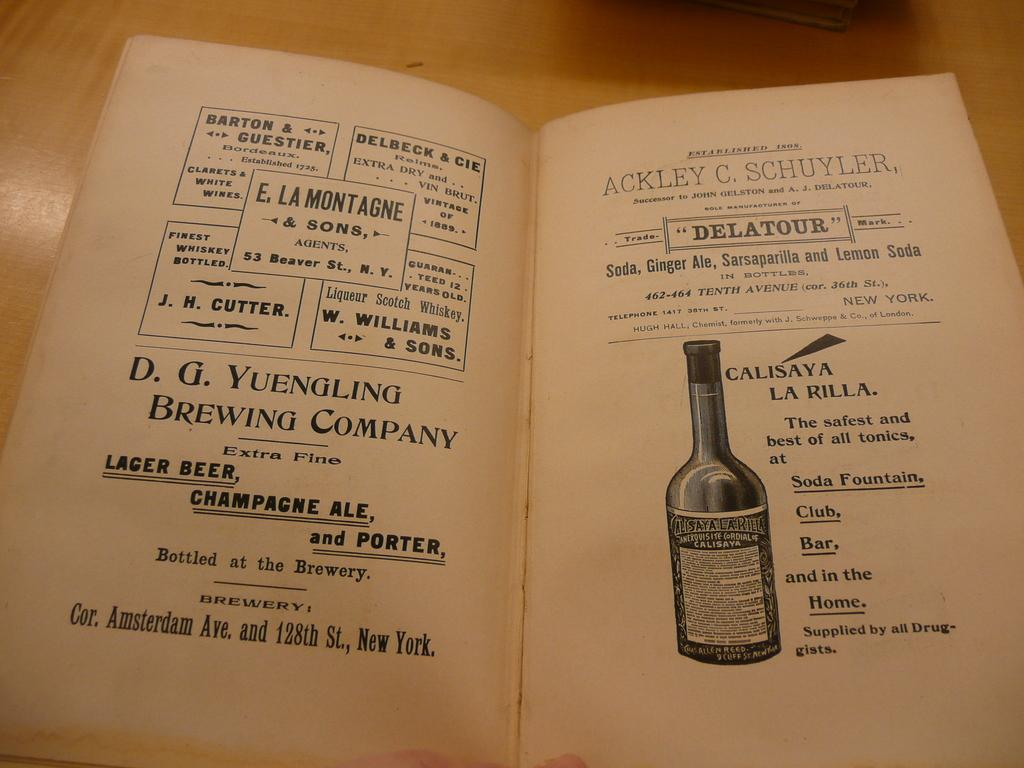<image>
Present a compact description of the photo's key features. The text indicates that this illustration of a bottle is of Calisaya La Rilla. 